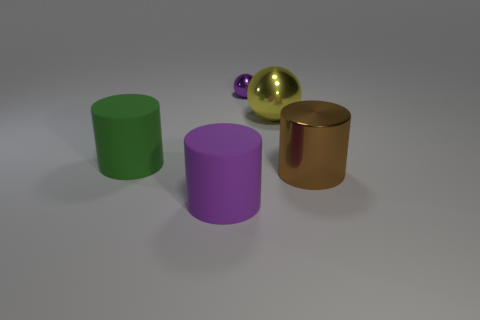Subtract all large green cylinders. How many cylinders are left? 2 Add 1 large rubber objects. How many objects exist? 6 Subtract all brown cylinders. How many cylinders are left? 2 Subtract 0 cyan balls. How many objects are left? 5 Subtract all cylinders. How many objects are left? 2 Subtract 2 cylinders. How many cylinders are left? 1 Subtract all blue balls. Subtract all yellow cubes. How many balls are left? 2 Subtract all yellow cylinders. How many yellow spheres are left? 1 Subtract all balls. Subtract all purple cylinders. How many objects are left? 2 Add 3 big cylinders. How many big cylinders are left? 6 